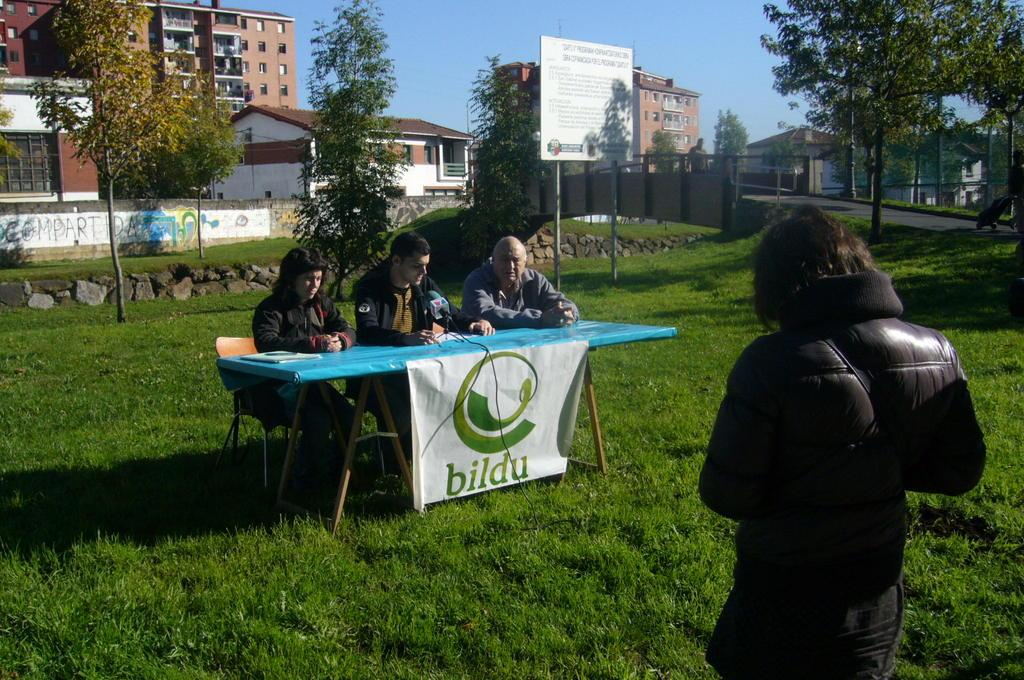<image>
Create a compact narrative representing the image presented. People sitting behind a table that says BILDU on it. 